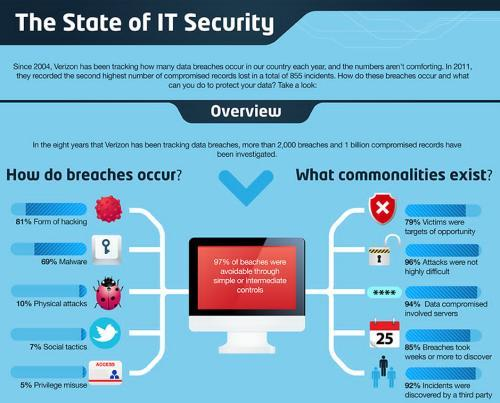What is the second most common way in which security breaches occur?
Answer the question with a short phrase. Malware How many of the breaches could have been avoided? 97% Which are the three less used methods in security breaches? physical attacks, social tactics, privilege misuse what is the most common way security breaches occur? hacking 